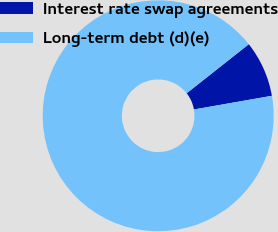Convert chart. <chart><loc_0><loc_0><loc_500><loc_500><pie_chart><fcel>Interest rate swap agreements<fcel>Long-term debt (d)(e)<nl><fcel>7.87%<fcel>92.13%<nl></chart> 